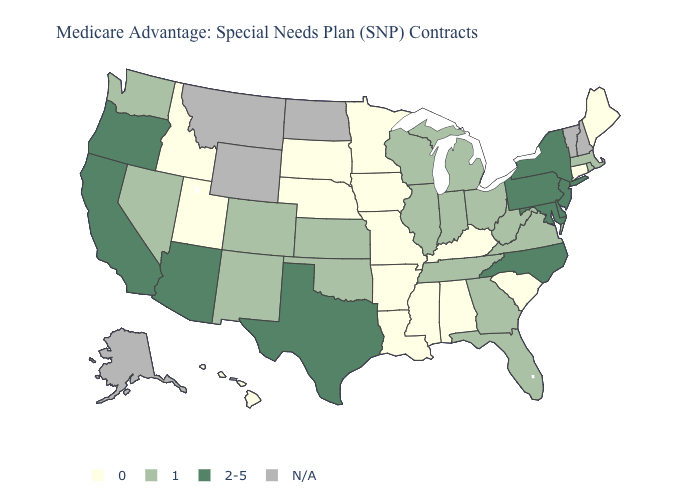What is the value of Nebraska?
Keep it brief. 0. What is the value of Mississippi?
Concise answer only. 0. Which states have the lowest value in the Northeast?
Quick response, please. Connecticut, Maine. Name the states that have a value in the range 2-5?
Quick response, please. Arizona, California, Delaware, Maryland, North Carolina, New Jersey, New York, Oregon, Pennsylvania, Texas. Name the states that have a value in the range N/A?
Concise answer only. Alaska, Montana, North Dakota, New Hampshire, Vermont, Wyoming. What is the value of New Jersey?
Give a very brief answer. 2-5. What is the value of South Carolina?
Keep it brief. 0. Name the states that have a value in the range N/A?
Write a very short answer. Alaska, Montana, North Dakota, New Hampshire, Vermont, Wyoming. Is the legend a continuous bar?
Be succinct. No. Name the states that have a value in the range 0?
Quick response, please. Alabama, Arkansas, Connecticut, Hawaii, Iowa, Idaho, Kentucky, Louisiana, Maine, Minnesota, Missouri, Mississippi, Nebraska, South Carolina, South Dakota, Utah. What is the highest value in the USA?
Concise answer only. 2-5. What is the value of Vermont?
Answer briefly. N/A. Which states have the lowest value in the USA?
Answer briefly. Alabama, Arkansas, Connecticut, Hawaii, Iowa, Idaho, Kentucky, Louisiana, Maine, Minnesota, Missouri, Mississippi, Nebraska, South Carolina, South Dakota, Utah. Name the states that have a value in the range 0?
Quick response, please. Alabama, Arkansas, Connecticut, Hawaii, Iowa, Idaho, Kentucky, Louisiana, Maine, Minnesota, Missouri, Mississippi, Nebraska, South Carolina, South Dakota, Utah. What is the highest value in the MidWest ?
Write a very short answer. 1. 